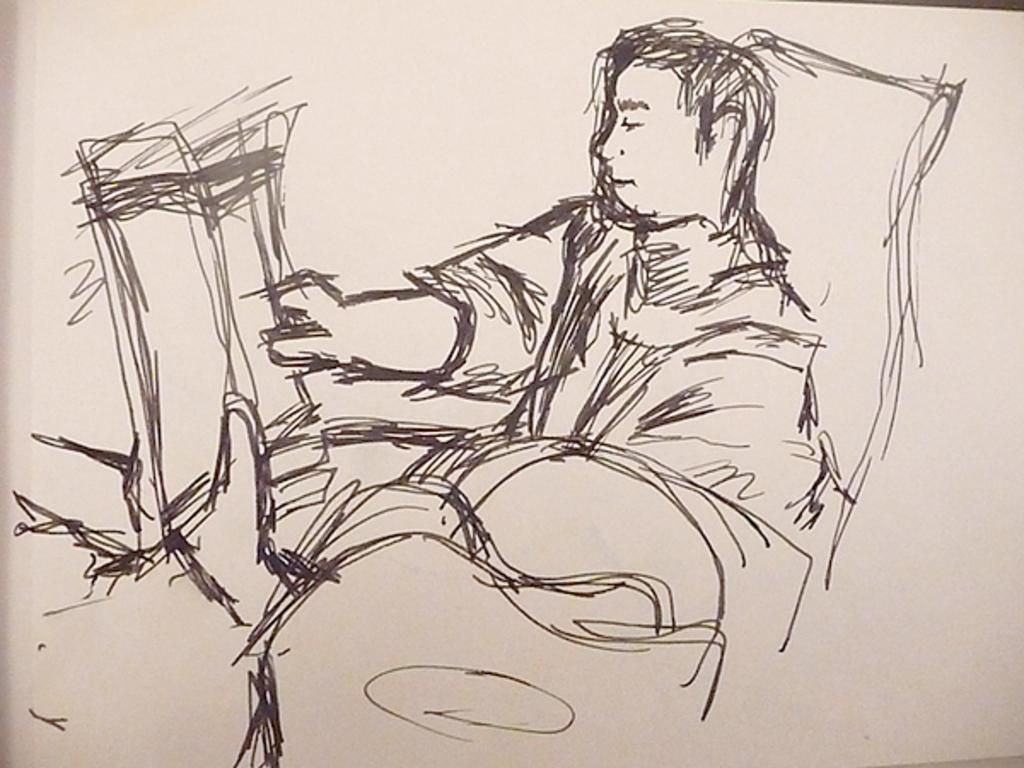How would you summarize this image in a sentence or two? This is a picture of a drawing. In this picture there is a person. 